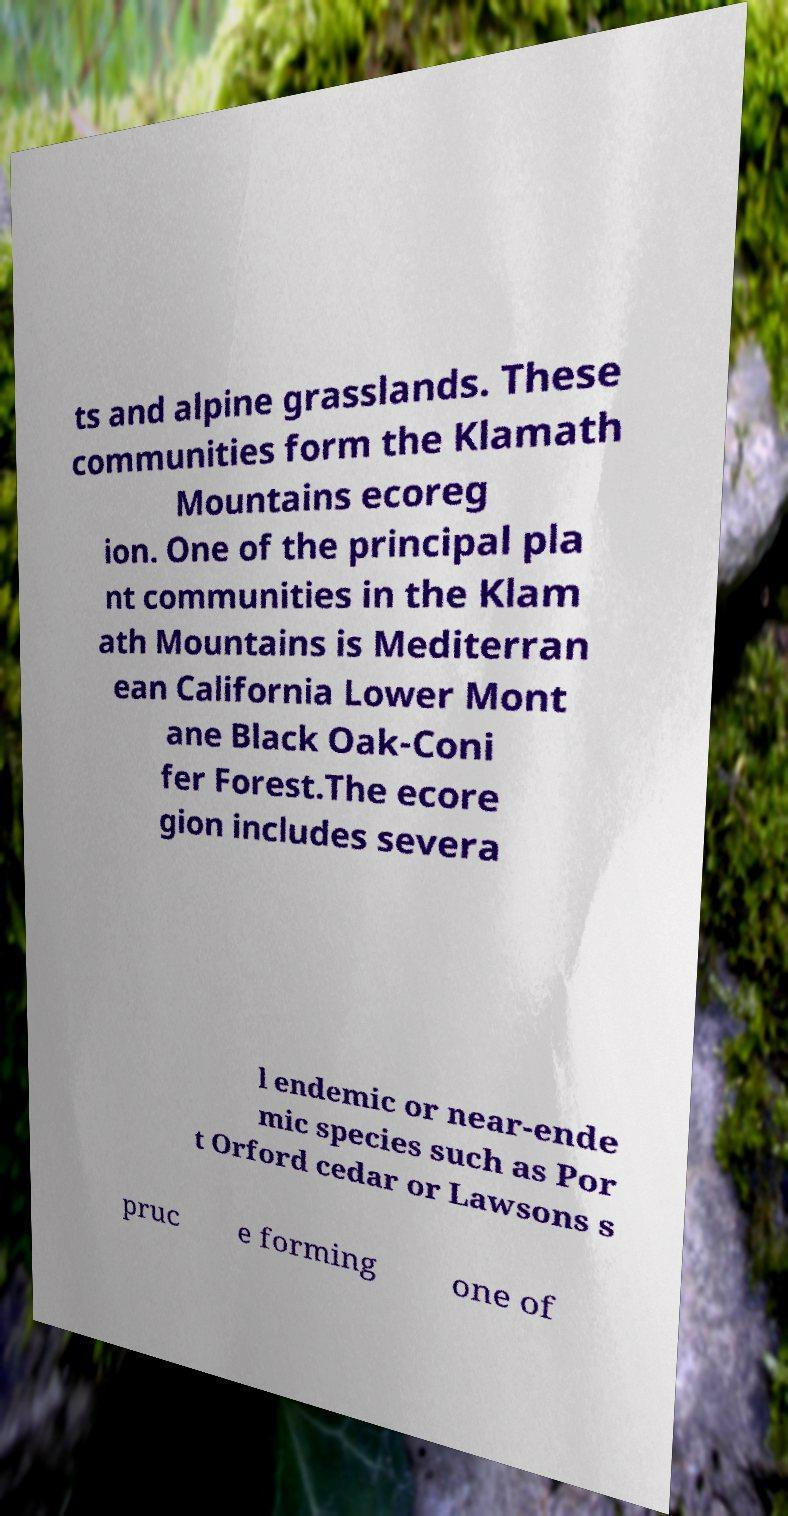For documentation purposes, I need the text within this image transcribed. Could you provide that? ts and alpine grasslands. These communities form the Klamath Mountains ecoreg ion. One of the principal pla nt communities in the Klam ath Mountains is Mediterran ean California Lower Mont ane Black Oak-Coni fer Forest.The ecore gion includes severa l endemic or near-ende mic species such as Por t Orford cedar or Lawsons s pruc e forming one of 